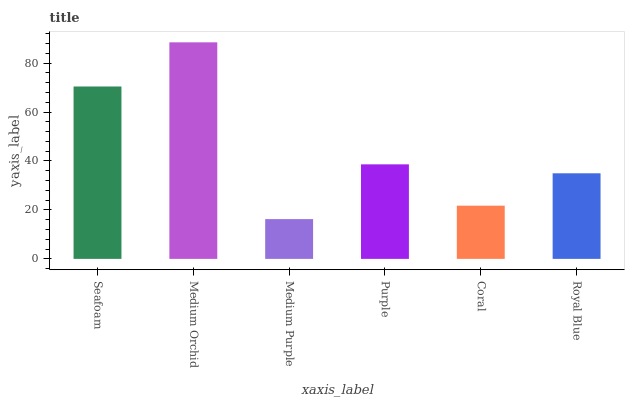Is Medium Purple the minimum?
Answer yes or no. Yes. Is Medium Orchid the maximum?
Answer yes or no. Yes. Is Medium Orchid the minimum?
Answer yes or no. No. Is Medium Purple the maximum?
Answer yes or no. No. Is Medium Orchid greater than Medium Purple?
Answer yes or no. Yes. Is Medium Purple less than Medium Orchid?
Answer yes or no. Yes. Is Medium Purple greater than Medium Orchid?
Answer yes or no. No. Is Medium Orchid less than Medium Purple?
Answer yes or no. No. Is Purple the high median?
Answer yes or no. Yes. Is Royal Blue the low median?
Answer yes or no. Yes. Is Coral the high median?
Answer yes or no. No. Is Seafoam the low median?
Answer yes or no. No. 